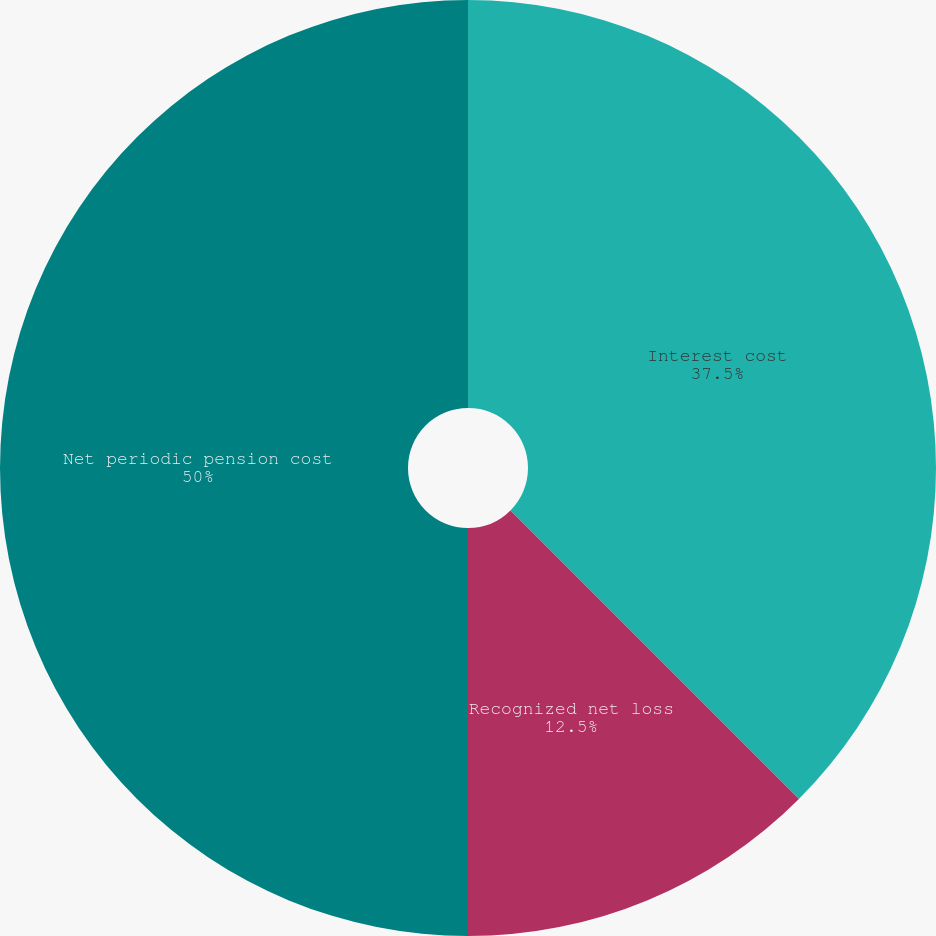Convert chart to OTSL. <chart><loc_0><loc_0><loc_500><loc_500><pie_chart><fcel>Interest cost<fcel>Recognized net loss<fcel>Net periodic pension cost<nl><fcel>37.5%<fcel>12.5%<fcel>50.0%<nl></chart> 